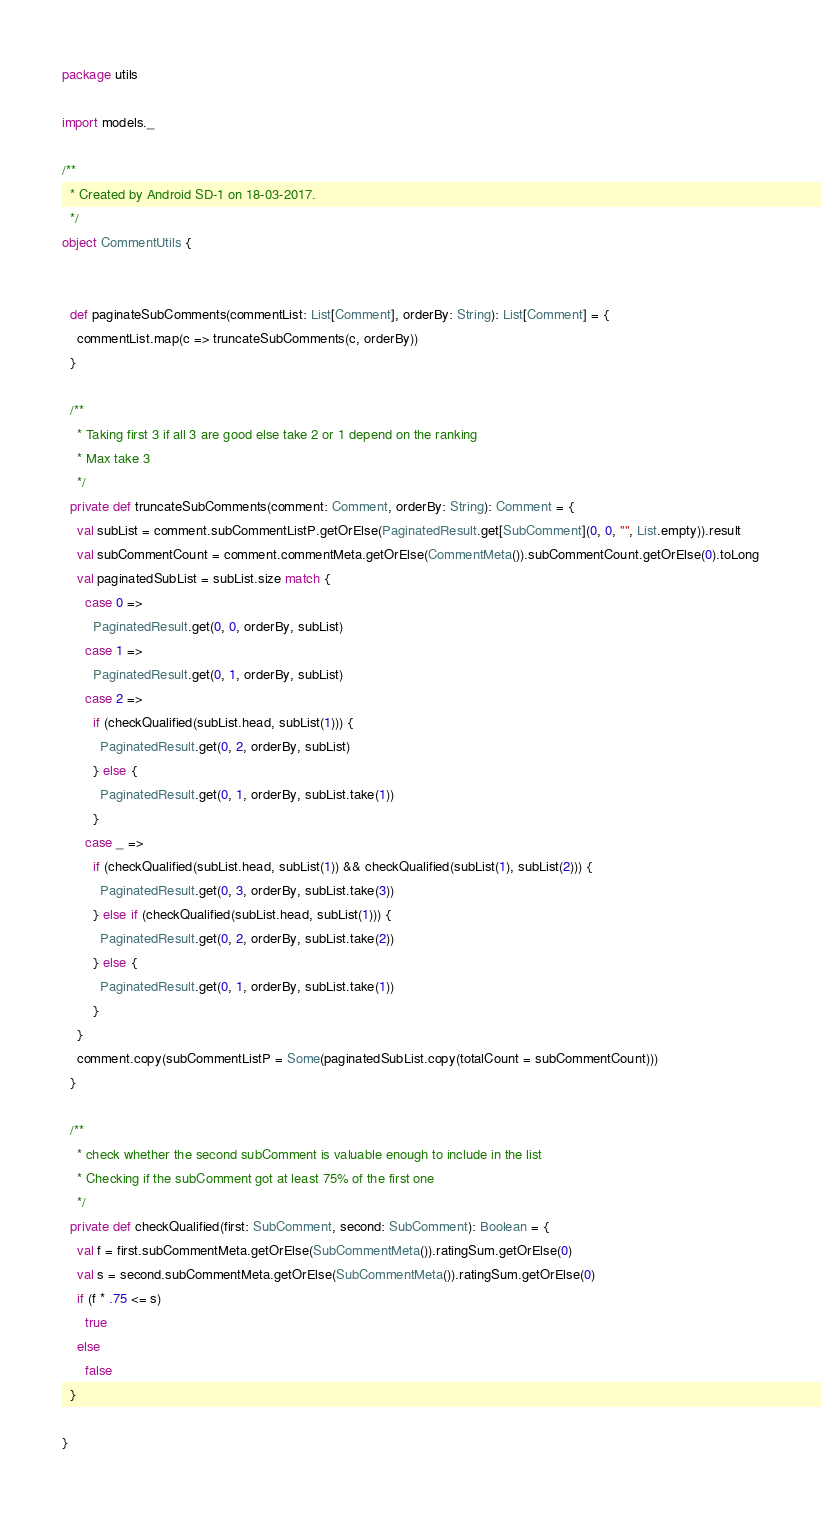Convert code to text. <code><loc_0><loc_0><loc_500><loc_500><_Scala_>package utils

import models._

/**
  * Created by Android SD-1 on 18-03-2017.
  */
object CommentUtils {


  def paginateSubComments(commentList: List[Comment], orderBy: String): List[Comment] = {
    commentList.map(c => truncateSubComments(c, orderBy))
  }

  /**
    * Taking first 3 if all 3 are good else take 2 or 1 depend on the ranking
    * Max take 3
    */
  private def truncateSubComments(comment: Comment, orderBy: String): Comment = {
    val subList = comment.subCommentListP.getOrElse(PaginatedResult.get[SubComment](0, 0, "", List.empty)).result
    val subCommentCount = comment.commentMeta.getOrElse(CommentMeta()).subCommentCount.getOrElse(0).toLong
    val paginatedSubList = subList.size match {
      case 0 =>
        PaginatedResult.get(0, 0, orderBy, subList)
      case 1 =>
        PaginatedResult.get(0, 1, orderBy, subList)
      case 2 =>
        if (checkQualified(subList.head, subList(1))) {
          PaginatedResult.get(0, 2, orderBy, subList)
        } else {
          PaginatedResult.get(0, 1, orderBy, subList.take(1))
        }
      case _ =>
        if (checkQualified(subList.head, subList(1)) && checkQualified(subList(1), subList(2))) {
          PaginatedResult.get(0, 3, orderBy, subList.take(3))
        } else if (checkQualified(subList.head, subList(1))) {
          PaginatedResult.get(0, 2, orderBy, subList.take(2))
        } else {
          PaginatedResult.get(0, 1, orderBy, subList.take(1))
        }
    }
    comment.copy(subCommentListP = Some(paginatedSubList.copy(totalCount = subCommentCount)))
  }

  /**
    * check whether the second subComment is valuable enough to include in the list
    * Checking if the subComment got at least 75% of the first one
    */
  private def checkQualified(first: SubComment, second: SubComment): Boolean = {
    val f = first.subCommentMeta.getOrElse(SubCommentMeta()).ratingSum.getOrElse(0)
    val s = second.subCommentMeta.getOrElse(SubCommentMeta()).ratingSum.getOrElse(0)
    if (f * .75 <= s)
      true
    else
      false
  }

}</code> 